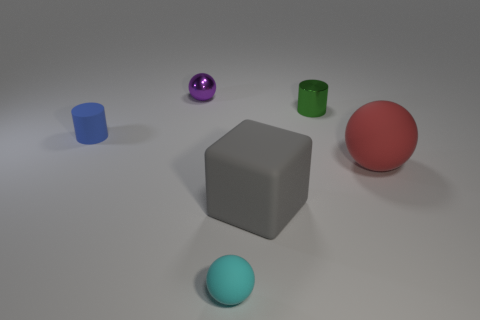Subtract all tiny purple metallic balls. How many balls are left? 2 Add 3 gray rubber blocks. How many objects exist? 9 Subtract all cylinders. How many objects are left? 4 Add 3 large things. How many large things are left? 5 Add 2 small cyan balls. How many small cyan balls exist? 3 Subtract 0 red cylinders. How many objects are left? 6 Subtract all large matte cubes. Subtract all tiny spheres. How many objects are left? 3 